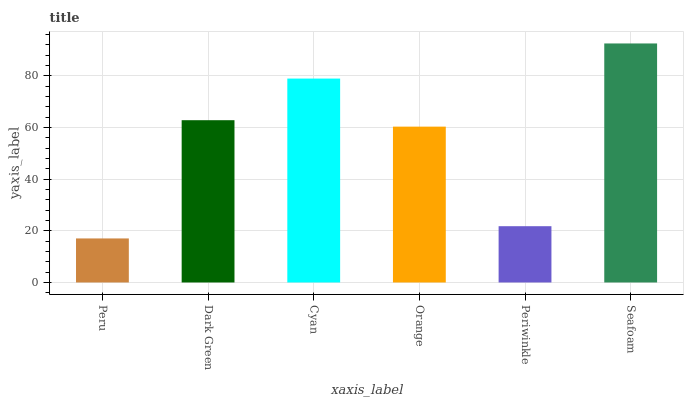Is Peru the minimum?
Answer yes or no. Yes. Is Seafoam the maximum?
Answer yes or no. Yes. Is Dark Green the minimum?
Answer yes or no. No. Is Dark Green the maximum?
Answer yes or no. No. Is Dark Green greater than Peru?
Answer yes or no. Yes. Is Peru less than Dark Green?
Answer yes or no. Yes. Is Peru greater than Dark Green?
Answer yes or no. No. Is Dark Green less than Peru?
Answer yes or no. No. Is Dark Green the high median?
Answer yes or no. Yes. Is Orange the low median?
Answer yes or no. Yes. Is Seafoam the high median?
Answer yes or no. No. Is Cyan the low median?
Answer yes or no. No. 